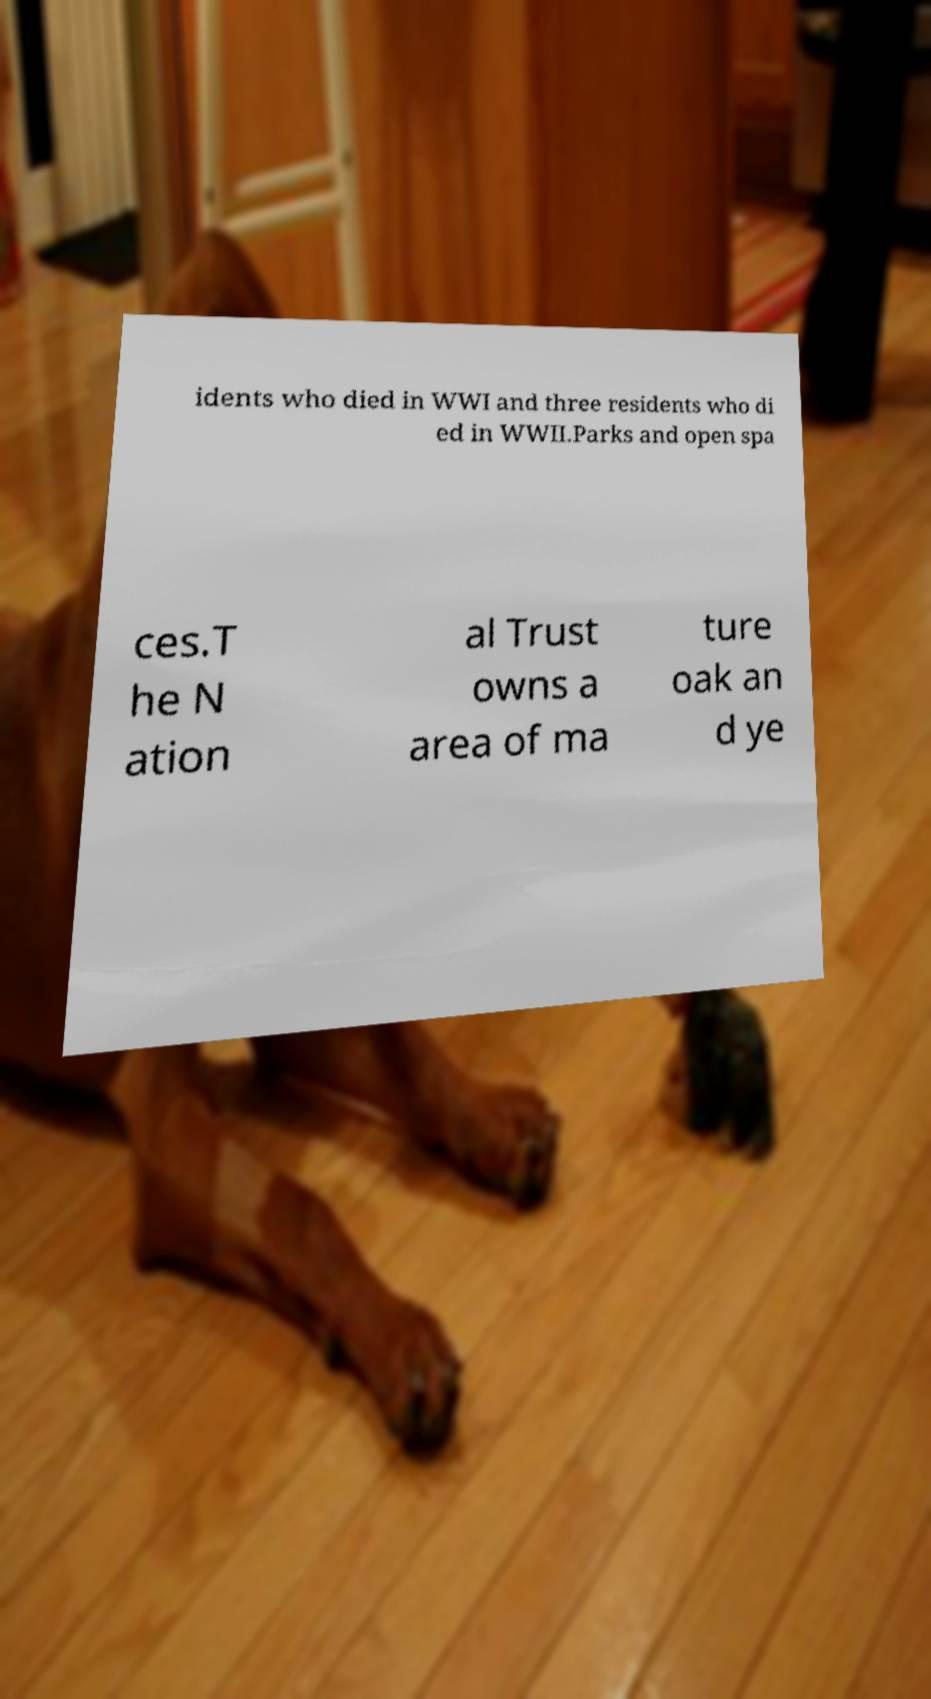What messages or text are displayed in this image? I need them in a readable, typed format. idents who died in WWI and three residents who di ed in WWII.Parks and open spa ces.T he N ation al Trust owns a area of ma ture oak an d ye 